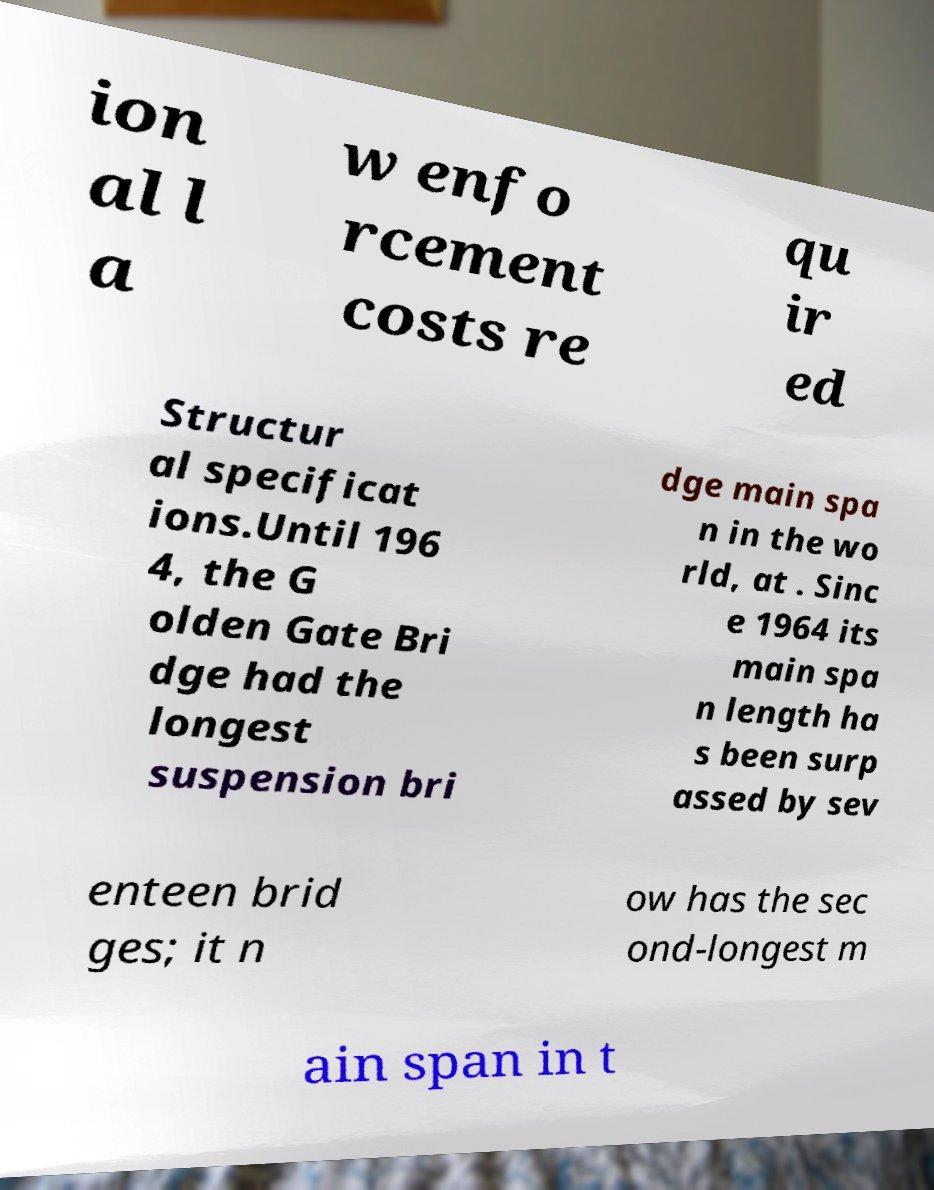Please identify and transcribe the text found in this image. ion al l a w enfo rcement costs re qu ir ed Structur al specificat ions.Until 196 4, the G olden Gate Bri dge had the longest suspension bri dge main spa n in the wo rld, at . Sinc e 1964 its main spa n length ha s been surp assed by sev enteen brid ges; it n ow has the sec ond-longest m ain span in t 